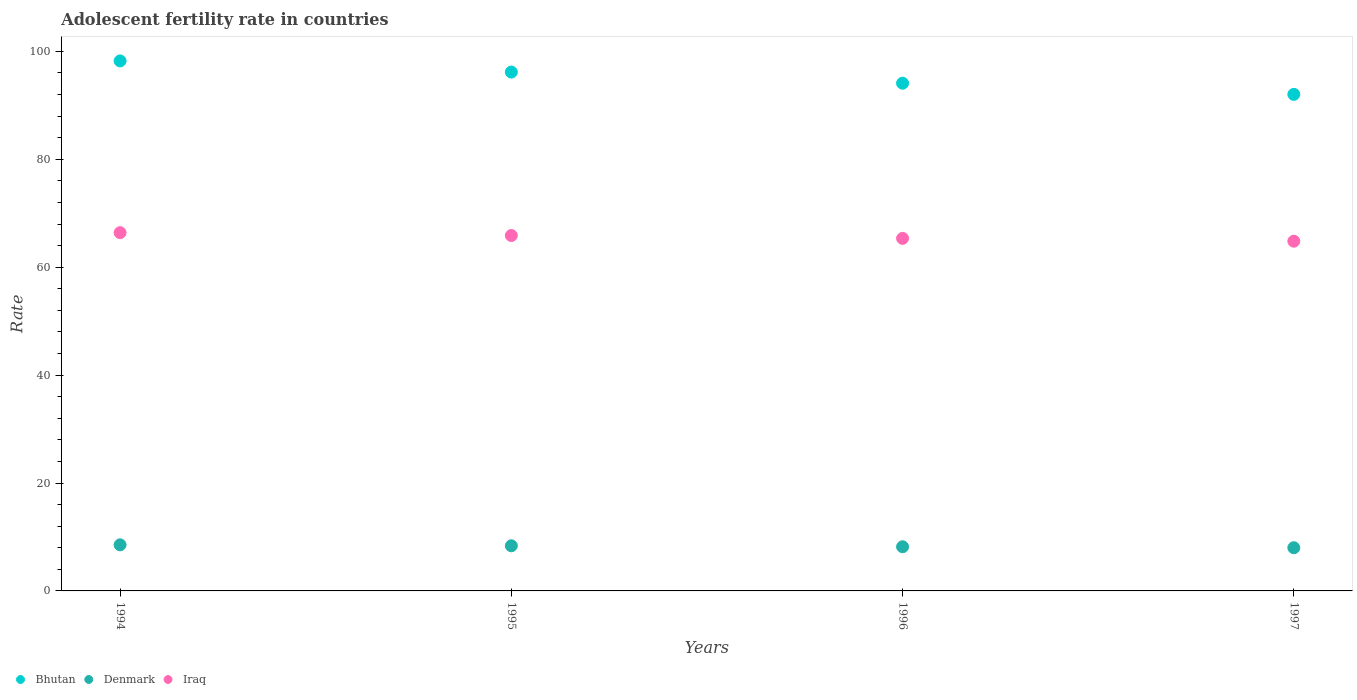How many different coloured dotlines are there?
Your answer should be very brief. 3. Is the number of dotlines equal to the number of legend labels?
Offer a terse response. Yes. What is the adolescent fertility rate in Bhutan in 1994?
Your response must be concise. 98.24. Across all years, what is the maximum adolescent fertility rate in Denmark?
Provide a succinct answer. 8.54. Across all years, what is the minimum adolescent fertility rate in Denmark?
Provide a short and direct response. 8.01. In which year was the adolescent fertility rate in Iraq maximum?
Offer a very short reply. 1994. What is the total adolescent fertility rate in Bhutan in the graph?
Provide a short and direct response. 380.55. What is the difference between the adolescent fertility rate in Denmark in 1994 and that in 1995?
Offer a terse response. 0.18. What is the difference between the adolescent fertility rate in Denmark in 1994 and the adolescent fertility rate in Iraq in 1997?
Your answer should be compact. -56.28. What is the average adolescent fertility rate in Iraq per year?
Provide a short and direct response. 65.61. In the year 1997, what is the difference between the adolescent fertility rate in Denmark and adolescent fertility rate in Bhutan?
Your answer should be very brief. -84.03. In how many years, is the adolescent fertility rate in Iraq greater than 44?
Give a very brief answer. 4. What is the ratio of the adolescent fertility rate in Iraq in 1994 to that in 1997?
Provide a succinct answer. 1.02. What is the difference between the highest and the second highest adolescent fertility rate in Bhutan?
Keep it short and to the point. 2.07. What is the difference between the highest and the lowest adolescent fertility rate in Iraq?
Your answer should be very brief. 1.58. Is the sum of the adolescent fertility rate in Denmark in 1994 and 1995 greater than the maximum adolescent fertility rate in Bhutan across all years?
Offer a very short reply. No. Is it the case that in every year, the sum of the adolescent fertility rate in Denmark and adolescent fertility rate in Bhutan  is greater than the adolescent fertility rate in Iraq?
Provide a short and direct response. Yes. Does the adolescent fertility rate in Bhutan monotonically increase over the years?
Ensure brevity in your answer.  No. What is the difference between two consecutive major ticks on the Y-axis?
Offer a terse response. 20. Are the values on the major ticks of Y-axis written in scientific E-notation?
Ensure brevity in your answer.  No. Where does the legend appear in the graph?
Your answer should be compact. Bottom left. How are the legend labels stacked?
Your answer should be compact. Horizontal. What is the title of the graph?
Make the answer very short. Adolescent fertility rate in countries. What is the label or title of the Y-axis?
Your response must be concise. Rate. What is the Rate in Bhutan in 1994?
Provide a succinct answer. 98.24. What is the Rate of Denmark in 1994?
Your answer should be very brief. 8.54. What is the Rate of Iraq in 1994?
Provide a succinct answer. 66.4. What is the Rate of Bhutan in 1995?
Give a very brief answer. 96.17. What is the Rate in Denmark in 1995?
Ensure brevity in your answer.  8.36. What is the Rate in Iraq in 1995?
Make the answer very short. 65.88. What is the Rate in Bhutan in 1996?
Your answer should be compact. 94.1. What is the Rate in Denmark in 1996?
Keep it short and to the point. 8.19. What is the Rate in Iraq in 1996?
Your answer should be compact. 65.35. What is the Rate of Bhutan in 1997?
Offer a terse response. 92.04. What is the Rate in Denmark in 1997?
Your answer should be very brief. 8.01. What is the Rate of Iraq in 1997?
Give a very brief answer. 64.82. Across all years, what is the maximum Rate in Bhutan?
Provide a succinct answer. 98.24. Across all years, what is the maximum Rate in Denmark?
Offer a terse response. 8.54. Across all years, what is the maximum Rate in Iraq?
Your response must be concise. 66.4. Across all years, what is the minimum Rate of Bhutan?
Provide a short and direct response. 92.04. Across all years, what is the minimum Rate in Denmark?
Your response must be concise. 8.01. Across all years, what is the minimum Rate in Iraq?
Give a very brief answer. 64.82. What is the total Rate of Bhutan in the graph?
Provide a succinct answer. 380.55. What is the total Rate of Denmark in the graph?
Make the answer very short. 33.1. What is the total Rate of Iraq in the graph?
Your response must be concise. 262.45. What is the difference between the Rate in Bhutan in 1994 and that in 1995?
Offer a very short reply. 2.07. What is the difference between the Rate of Denmark in 1994 and that in 1995?
Provide a short and direct response. 0.18. What is the difference between the Rate of Iraq in 1994 and that in 1995?
Your answer should be very brief. 0.53. What is the difference between the Rate of Bhutan in 1994 and that in 1996?
Your answer should be compact. 4.13. What is the difference between the Rate in Denmark in 1994 and that in 1996?
Your answer should be compact. 0.36. What is the difference between the Rate in Iraq in 1994 and that in 1996?
Offer a terse response. 1.05. What is the difference between the Rate in Bhutan in 1994 and that in 1997?
Your answer should be compact. 6.2. What is the difference between the Rate in Denmark in 1994 and that in 1997?
Your answer should be compact. 0.54. What is the difference between the Rate in Iraq in 1994 and that in 1997?
Make the answer very short. 1.58. What is the difference between the Rate in Bhutan in 1995 and that in 1996?
Keep it short and to the point. 2.07. What is the difference between the Rate in Denmark in 1995 and that in 1996?
Offer a terse response. 0.18. What is the difference between the Rate in Iraq in 1995 and that in 1996?
Keep it short and to the point. 0.53. What is the difference between the Rate in Bhutan in 1995 and that in 1997?
Offer a very short reply. 4.13. What is the difference between the Rate in Denmark in 1995 and that in 1997?
Make the answer very short. 0.36. What is the difference between the Rate of Iraq in 1995 and that in 1997?
Give a very brief answer. 1.05. What is the difference between the Rate of Bhutan in 1996 and that in 1997?
Make the answer very short. 2.07. What is the difference between the Rate of Denmark in 1996 and that in 1997?
Offer a terse response. 0.18. What is the difference between the Rate in Iraq in 1996 and that in 1997?
Provide a short and direct response. 0.53. What is the difference between the Rate of Bhutan in 1994 and the Rate of Denmark in 1995?
Keep it short and to the point. 89.87. What is the difference between the Rate of Bhutan in 1994 and the Rate of Iraq in 1995?
Ensure brevity in your answer.  32.36. What is the difference between the Rate in Denmark in 1994 and the Rate in Iraq in 1995?
Ensure brevity in your answer.  -57.33. What is the difference between the Rate of Bhutan in 1994 and the Rate of Denmark in 1996?
Provide a short and direct response. 90.05. What is the difference between the Rate in Bhutan in 1994 and the Rate in Iraq in 1996?
Provide a succinct answer. 32.89. What is the difference between the Rate of Denmark in 1994 and the Rate of Iraq in 1996?
Your answer should be very brief. -56.81. What is the difference between the Rate of Bhutan in 1994 and the Rate of Denmark in 1997?
Keep it short and to the point. 90.23. What is the difference between the Rate in Bhutan in 1994 and the Rate in Iraq in 1997?
Make the answer very short. 33.41. What is the difference between the Rate in Denmark in 1994 and the Rate in Iraq in 1997?
Give a very brief answer. -56.28. What is the difference between the Rate of Bhutan in 1995 and the Rate of Denmark in 1996?
Your response must be concise. 87.98. What is the difference between the Rate of Bhutan in 1995 and the Rate of Iraq in 1996?
Your answer should be compact. 30.82. What is the difference between the Rate in Denmark in 1995 and the Rate in Iraq in 1996?
Ensure brevity in your answer.  -56.98. What is the difference between the Rate of Bhutan in 1995 and the Rate of Denmark in 1997?
Offer a terse response. 88.16. What is the difference between the Rate in Bhutan in 1995 and the Rate in Iraq in 1997?
Offer a very short reply. 31.35. What is the difference between the Rate in Denmark in 1995 and the Rate in Iraq in 1997?
Your answer should be very brief. -56.46. What is the difference between the Rate in Bhutan in 1996 and the Rate in Denmark in 1997?
Ensure brevity in your answer.  86.1. What is the difference between the Rate of Bhutan in 1996 and the Rate of Iraq in 1997?
Provide a short and direct response. 29.28. What is the difference between the Rate in Denmark in 1996 and the Rate in Iraq in 1997?
Provide a succinct answer. -56.64. What is the average Rate of Bhutan per year?
Make the answer very short. 95.14. What is the average Rate in Denmark per year?
Your answer should be compact. 8.28. What is the average Rate of Iraq per year?
Your response must be concise. 65.61. In the year 1994, what is the difference between the Rate of Bhutan and Rate of Denmark?
Provide a short and direct response. 89.69. In the year 1994, what is the difference between the Rate of Bhutan and Rate of Iraq?
Offer a terse response. 31.83. In the year 1994, what is the difference between the Rate in Denmark and Rate in Iraq?
Give a very brief answer. -57.86. In the year 1995, what is the difference between the Rate in Bhutan and Rate in Denmark?
Your answer should be very brief. 87.81. In the year 1995, what is the difference between the Rate in Bhutan and Rate in Iraq?
Your answer should be very brief. 30.29. In the year 1995, what is the difference between the Rate of Denmark and Rate of Iraq?
Your answer should be compact. -57.51. In the year 1996, what is the difference between the Rate in Bhutan and Rate in Denmark?
Provide a succinct answer. 85.92. In the year 1996, what is the difference between the Rate of Bhutan and Rate of Iraq?
Your response must be concise. 28.75. In the year 1996, what is the difference between the Rate of Denmark and Rate of Iraq?
Your response must be concise. -57.16. In the year 1997, what is the difference between the Rate in Bhutan and Rate in Denmark?
Ensure brevity in your answer.  84.03. In the year 1997, what is the difference between the Rate in Bhutan and Rate in Iraq?
Provide a short and direct response. 27.21. In the year 1997, what is the difference between the Rate of Denmark and Rate of Iraq?
Provide a succinct answer. -56.81. What is the ratio of the Rate of Bhutan in 1994 to that in 1995?
Ensure brevity in your answer.  1.02. What is the ratio of the Rate of Denmark in 1994 to that in 1995?
Offer a terse response. 1.02. What is the ratio of the Rate in Iraq in 1994 to that in 1995?
Give a very brief answer. 1.01. What is the ratio of the Rate in Bhutan in 1994 to that in 1996?
Provide a succinct answer. 1.04. What is the ratio of the Rate of Denmark in 1994 to that in 1996?
Your answer should be compact. 1.04. What is the ratio of the Rate in Iraq in 1994 to that in 1996?
Offer a terse response. 1.02. What is the ratio of the Rate of Bhutan in 1994 to that in 1997?
Offer a very short reply. 1.07. What is the ratio of the Rate in Denmark in 1994 to that in 1997?
Give a very brief answer. 1.07. What is the ratio of the Rate of Iraq in 1994 to that in 1997?
Keep it short and to the point. 1.02. What is the ratio of the Rate in Bhutan in 1995 to that in 1996?
Give a very brief answer. 1.02. What is the ratio of the Rate in Denmark in 1995 to that in 1996?
Make the answer very short. 1.02. What is the ratio of the Rate in Bhutan in 1995 to that in 1997?
Offer a very short reply. 1.04. What is the ratio of the Rate in Denmark in 1995 to that in 1997?
Your response must be concise. 1.04. What is the ratio of the Rate of Iraq in 1995 to that in 1997?
Provide a short and direct response. 1.02. What is the ratio of the Rate of Bhutan in 1996 to that in 1997?
Offer a terse response. 1.02. What is the ratio of the Rate of Denmark in 1996 to that in 1997?
Provide a succinct answer. 1.02. What is the difference between the highest and the second highest Rate of Bhutan?
Give a very brief answer. 2.07. What is the difference between the highest and the second highest Rate of Denmark?
Your response must be concise. 0.18. What is the difference between the highest and the second highest Rate in Iraq?
Your answer should be compact. 0.53. What is the difference between the highest and the lowest Rate of Bhutan?
Your answer should be very brief. 6.2. What is the difference between the highest and the lowest Rate in Denmark?
Make the answer very short. 0.54. What is the difference between the highest and the lowest Rate in Iraq?
Ensure brevity in your answer.  1.58. 